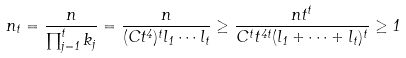Convert formula to latex. <formula><loc_0><loc_0><loc_500><loc_500>n _ { t } = \frac { n } { \prod _ { j = 1 } ^ { t } k _ { j } } = \frac { n } { ( C t ^ { 4 } ) ^ { t } l _ { 1 } \cdots l _ { t } } \geq \frac { n t ^ { t } } { C ^ { t } t ^ { 4 t } ( l _ { 1 } + \cdots + l _ { t } ) ^ { t } } \geq 1</formula> 